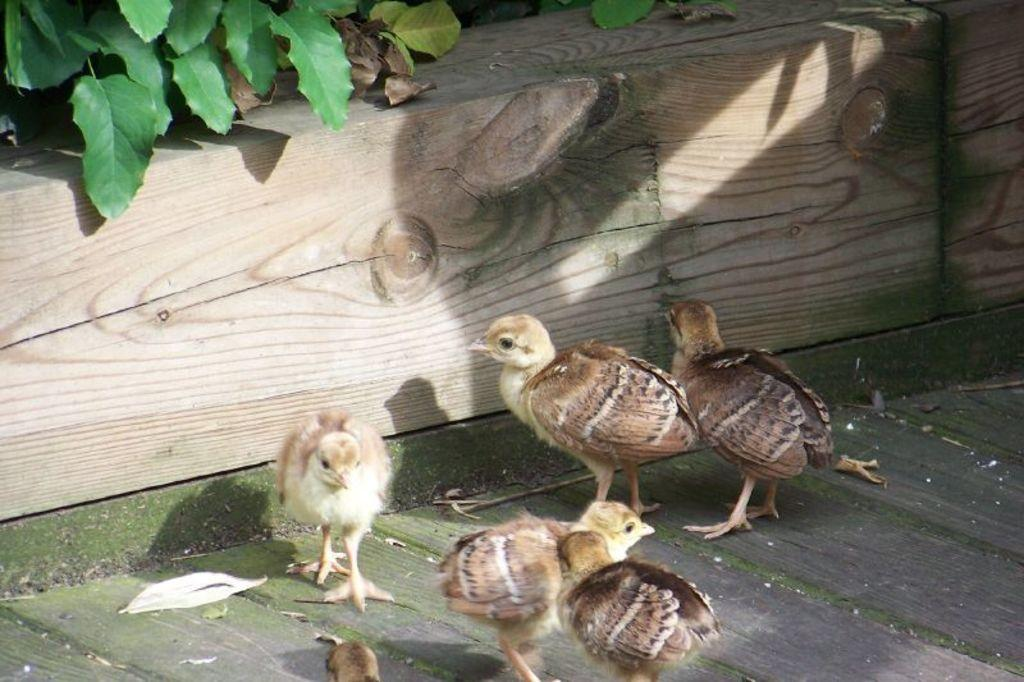What type of animals are in the image? There are chicks in the image. Where are the chicks located? The chicks are on a wooden floor. What can be seen in the background of the image? There is a plant in the background of the image. Can you see any tramps or slopes in the image? No, there are no tramps or slopes present in the image. Are there any icicles hanging from the plant in the background? No, there are no icicles visible in the image. 